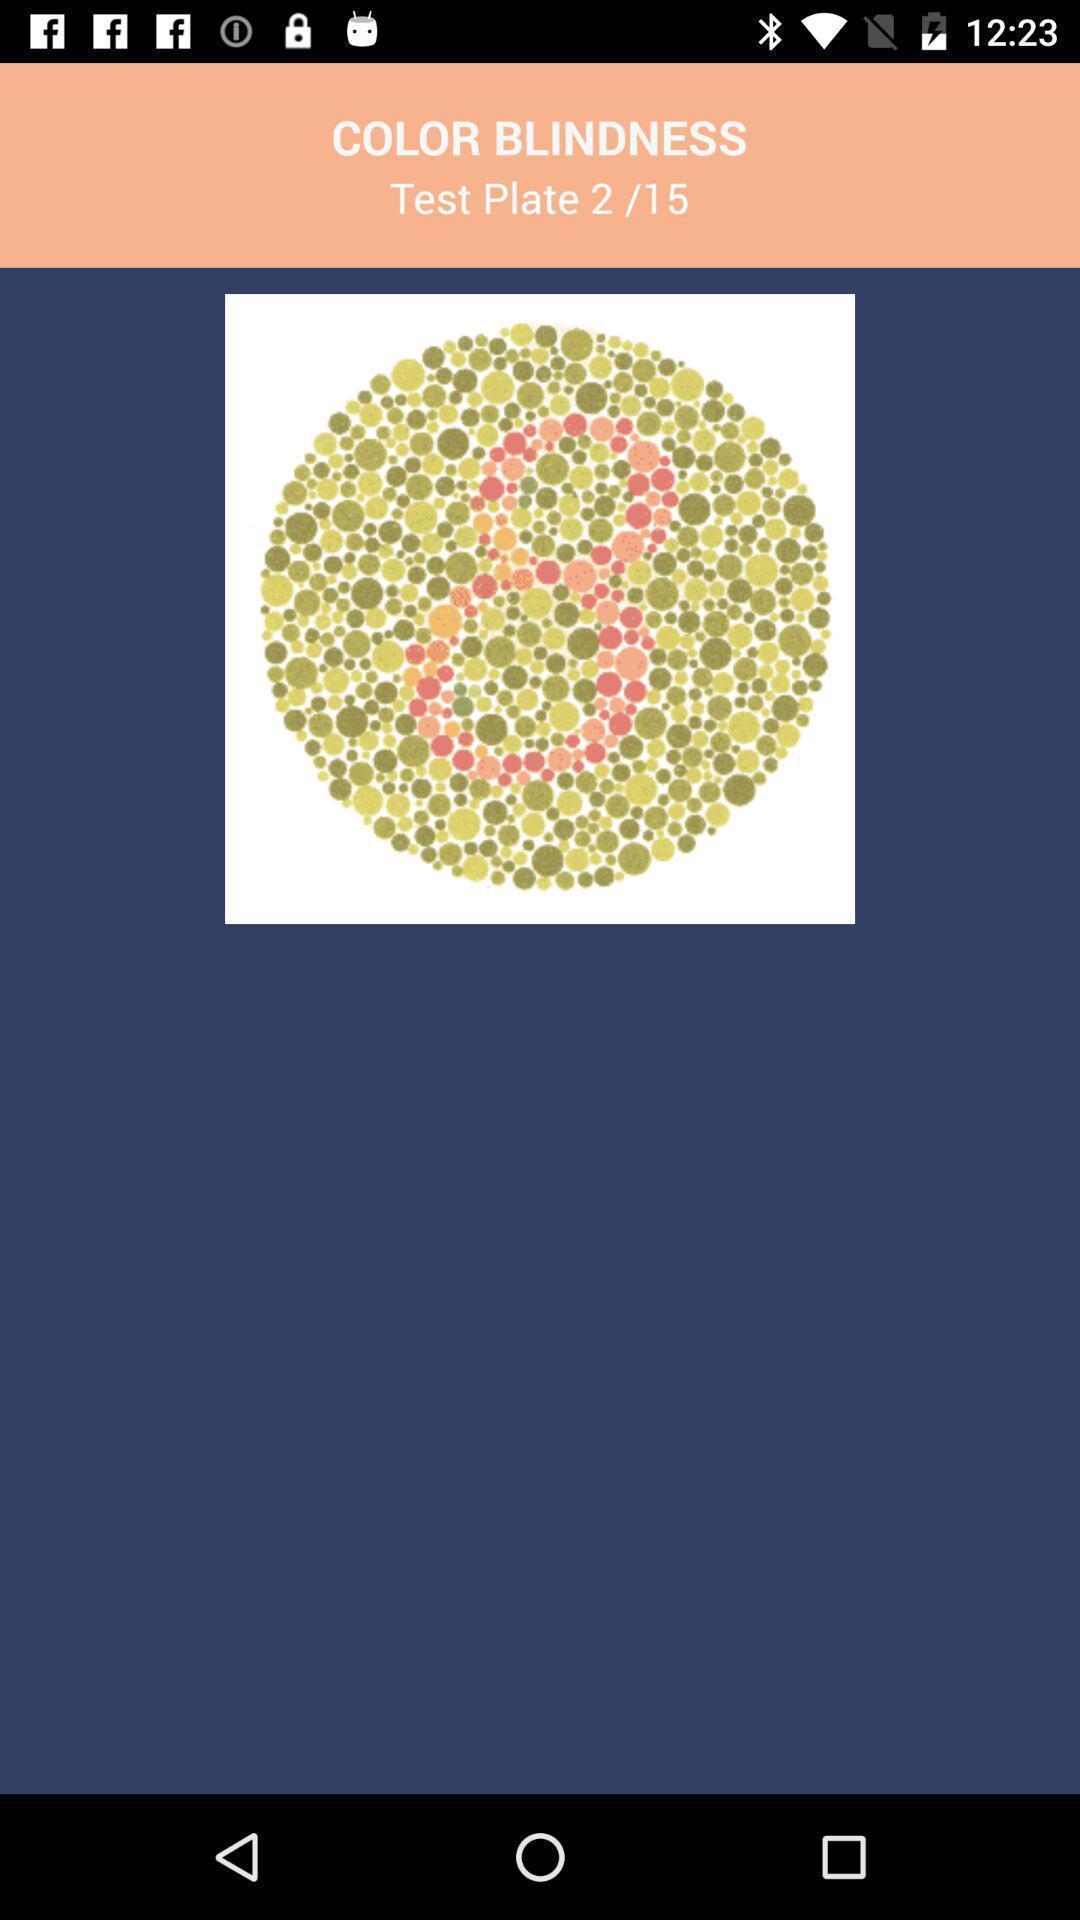Provide a detailed account of this screenshot. Window displaying a eye test page. 